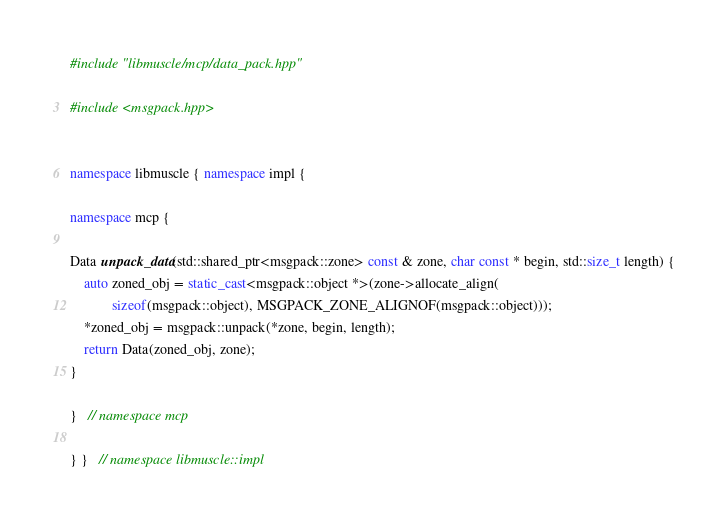Convert code to text. <code><loc_0><loc_0><loc_500><loc_500><_C++_>#include "libmuscle/mcp/data_pack.hpp"

#include <msgpack.hpp>


namespace libmuscle { namespace impl {

namespace mcp {

Data unpack_data(std::shared_ptr<msgpack::zone> const & zone, char const * begin, std::size_t length) {
    auto zoned_obj = static_cast<msgpack::object *>(zone->allocate_align(
            sizeof(msgpack::object), MSGPACK_ZONE_ALIGNOF(msgpack::object)));
    *zoned_obj = msgpack::unpack(*zone, begin, length);
    return Data(zoned_obj, zone);
}

}   // namespace mcp

} }   // namespace libmuscle::impl

</code> 